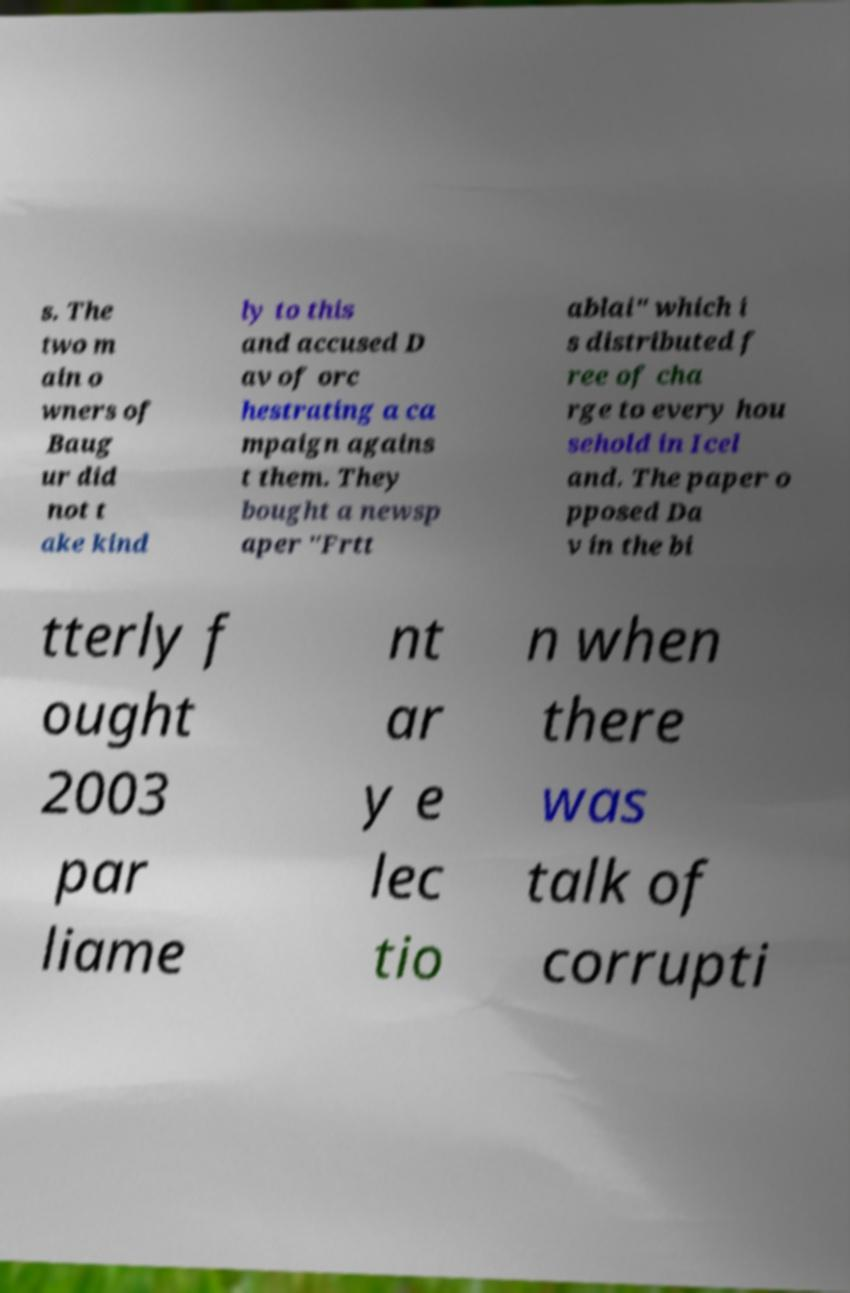Could you assist in decoding the text presented in this image and type it out clearly? s. The two m ain o wners of Baug ur did not t ake kind ly to this and accused D av of orc hestrating a ca mpaign agains t them. They bought a newsp aper "Frtt ablai" which i s distributed f ree of cha rge to every hou sehold in Icel and. The paper o pposed Da v in the bi tterly f ought 2003 par liame nt ar y e lec tio n when there was talk of corrupti 